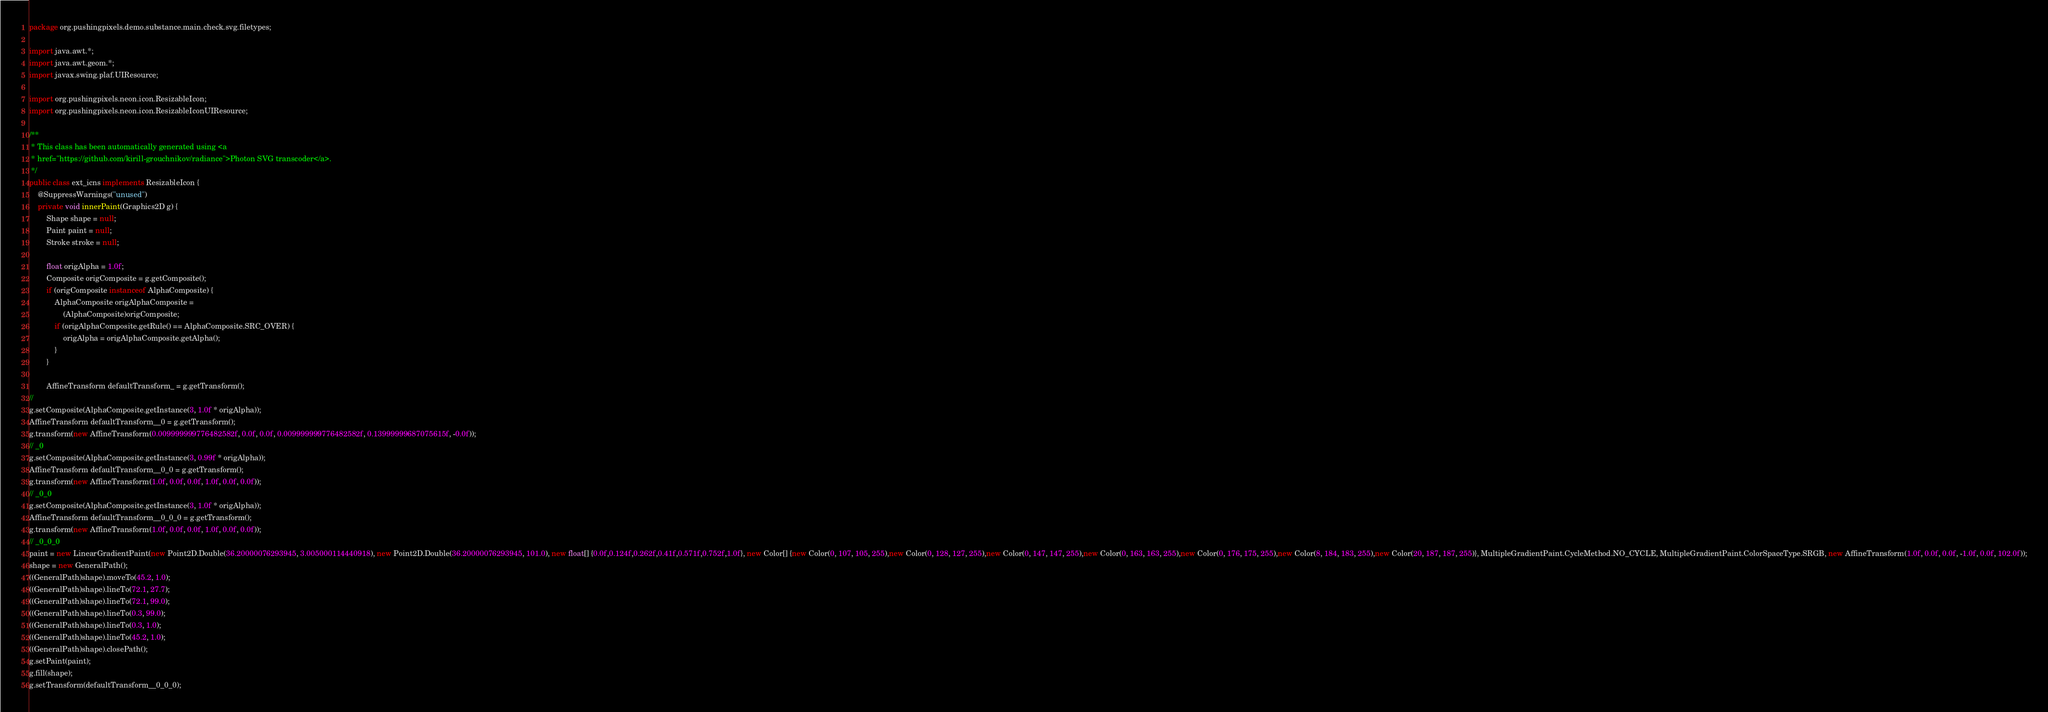<code> <loc_0><loc_0><loc_500><loc_500><_Java_>package org.pushingpixels.demo.substance.main.check.svg.filetypes;

import java.awt.*;
import java.awt.geom.*;
import javax.swing.plaf.UIResource;

import org.pushingpixels.neon.icon.ResizableIcon;
import org.pushingpixels.neon.icon.ResizableIconUIResource;

/**
 * This class has been automatically generated using <a
 * href="https://github.com/kirill-grouchnikov/radiance">Photon SVG transcoder</a>.
 */
public class ext_icns implements ResizableIcon {
    @SuppressWarnings("unused")
	private void innerPaint(Graphics2D g) {
        Shape shape = null;
        Paint paint = null;
        Stroke stroke = null;
         
        float origAlpha = 1.0f;
        Composite origComposite = g.getComposite();
        if (origComposite instanceof AlphaComposite) {
            AlphaComposite origAlphaComposite = 
                (AlphaComposite)origComposite;
            if (origAlphaComposite.getRule() == AlphaComposite.SRC_OVER) {
                origAlpha = origAlphaComposite.getAlpha();
            }
        }
        
	    AffineTransform defaultTransform_ = g.getTransform();
// 
g.setComposite(AlphaComposite.getInstance(3, 1.0f * origAlpha));
AffineTransform defaultTransform__0 = g.getTransform();
g.transform(new AffineTransform(0.009999999776482582f, 0.0f, 0.0f, 0.009999999776482582f, 0.13999999687075615f, -0.0f));
// _0
g.setComposite(AlphaComposite.getInstance(3, 0.99f * origAlpha));
AffineTransform defaultTransform__0_0 = g.getTransform();
g.transform(new AffineTransform(1.0f, 0.0f, 0.0f, 1.0f, 0.0f, 0.0f));
// _0_0
g.setComposite(AlphaComposite.getInstance(3, 1.0f * origAlpha));
AffineTransform defaultTransform__0_0_0 = g.getTransform();
g.transform(new AffineTransform(1.0f, 0.0f, 0.0f, 1.0f, 0.0f, 0.0f));
// _0_0_0
paint = new LinearGradientPaint(new Point2D.Double(36.20000076293945, 3.005000114440918), new Point2D.Double(36.20000076293945, 101.0), new float[] {0.0f,0.124f,0.262f,0.41f,0.571f,0.752f,1.0f}, new Color[] {new Color(0, 107, 105, 255),new Color(0, 128, 127, 255),new Color(0, 147, 147, 255),new Color(0, 163, 163, 255),new Color(0, 176, 175, 255),new Color(8, 184, 183, 255),new Color(20, 187, 187, 255)}, MultipleGradientPaint.CycleMethod.NO_CYCLE, MultipleGradientPaint.ColorSpaceType.SRGB, new AffineTransform(1.0f, 0.0f, 0.0f, -1.0f, 0.0f, 102.0f));
shape = new GeneralPath();
((GeneralPath)shape).moveTo(45.2, 1.0);
((GeneralPath)shape).lineTo(72.1, 27.7);
((GeneralPath)shape).lineTo(72.1, 99.0);
((GeneralPath)shape).lineTo(0.3, 99.0);
((GeneralPath)shape).lineTo(0.3, 1.0);
((GeneralPath)shape).lineTo(45.2, 1.0);
((GeneralPath)shape).closePath();
g.setPaint(paint);
g.fill(shape);
g.setTransform(defaultTransform__0_0_0);</code> 